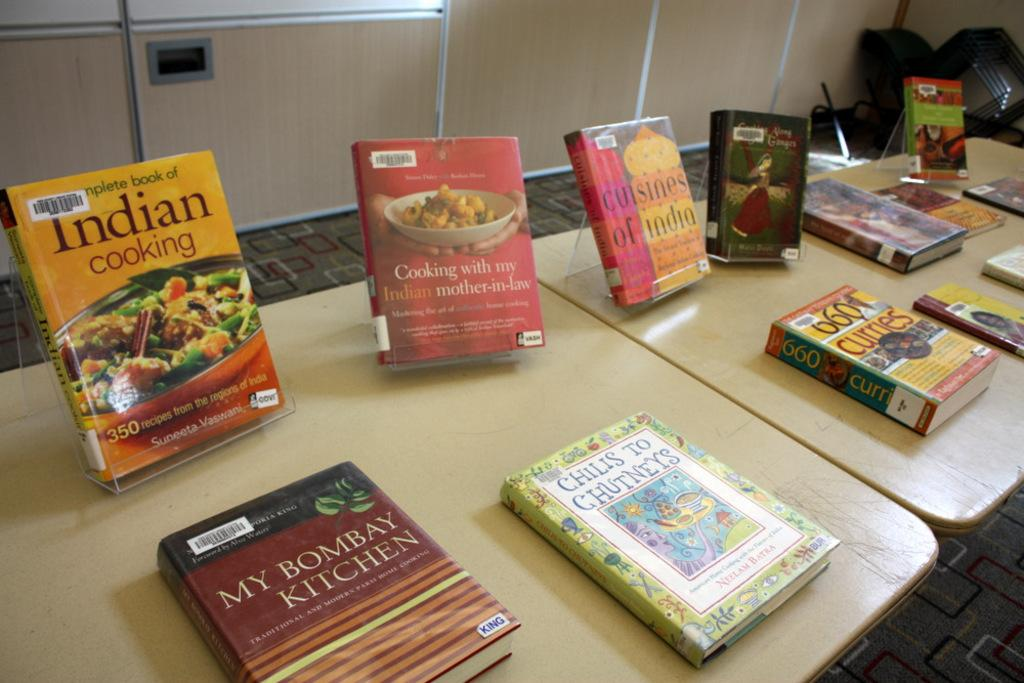<image>
Give a short and clear explanation of the subsequent image. A series of cook books sitting on a table with names like Indian Cooking and My Bombay Kitchen. 